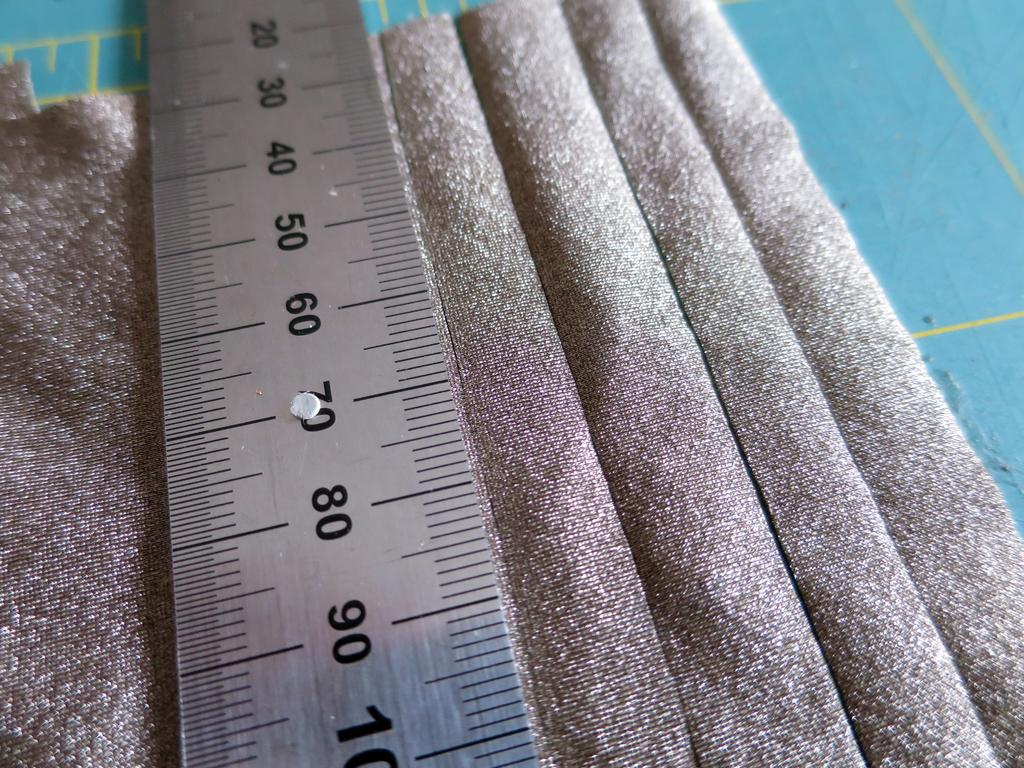<image>
Create a compact narrative representing the image presented. a ruler with many different digits on it 